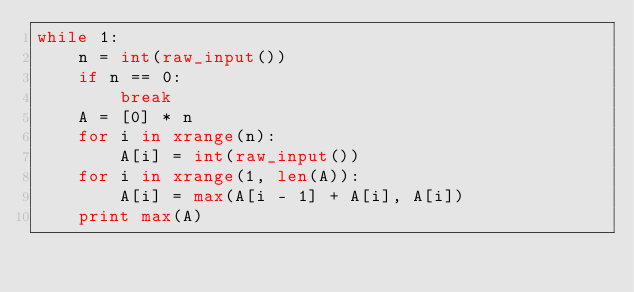<code> <loc_0><loc_0><loc_500><loc_500><_Python_>while 1:
    n = int(raw_input())
    if n == 0:
        break
    A = [0] * n
    for i in xrange(n):
        A[i] = int(raw_input())
    for i in xrange(1, len(A)):
        A[i] = max(A[i - 1] + A[i], A[i])
    print max(A)</code> 